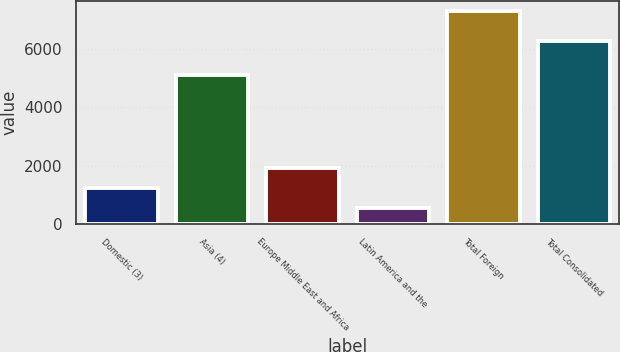Convert chart to OTSL. <chart><loc_0><loc_0><loc_500><loc_500><bar_chart><fcel>Domestic (3)<fcel>Asia (4)<fcel>Europe Middle East and Africa<fcel>Latin America and the<fcel>Total Foreign<fcel>Total Consolidated<nl><fcel>1223.3<fcel>5101<fcel>1898.6<fcel>548<fcel>7301<fcel>6276<nl></chart> 